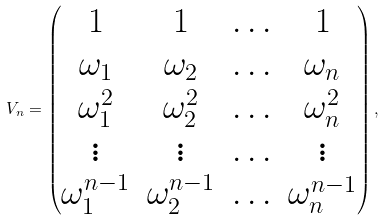<formula> <loc_0><loc_0><loc_500><loc_500>V _ { n } = \begin{pmatrix} 1 & 1 & \hdots & 1 \\ \omega _ { 1 } & \omega _ { 2 } & \hdots & \omega _ { n } \\ \omega _ { 1 } ^ { 2 } & \omega _ { 2 } ^ { 2 } & \hdots & \omega _ { n } ^ { 2 } \\ \vdots & \vdots & \hdots & \vdots \\ \omega _ { 1 } ^ { n - 1 } & \omega _ { 2 } ^ { n - 1 } & \hdots & \omega _ { n } ^ { n - 1 } \\ \end{pmatrix} ,</formula> 